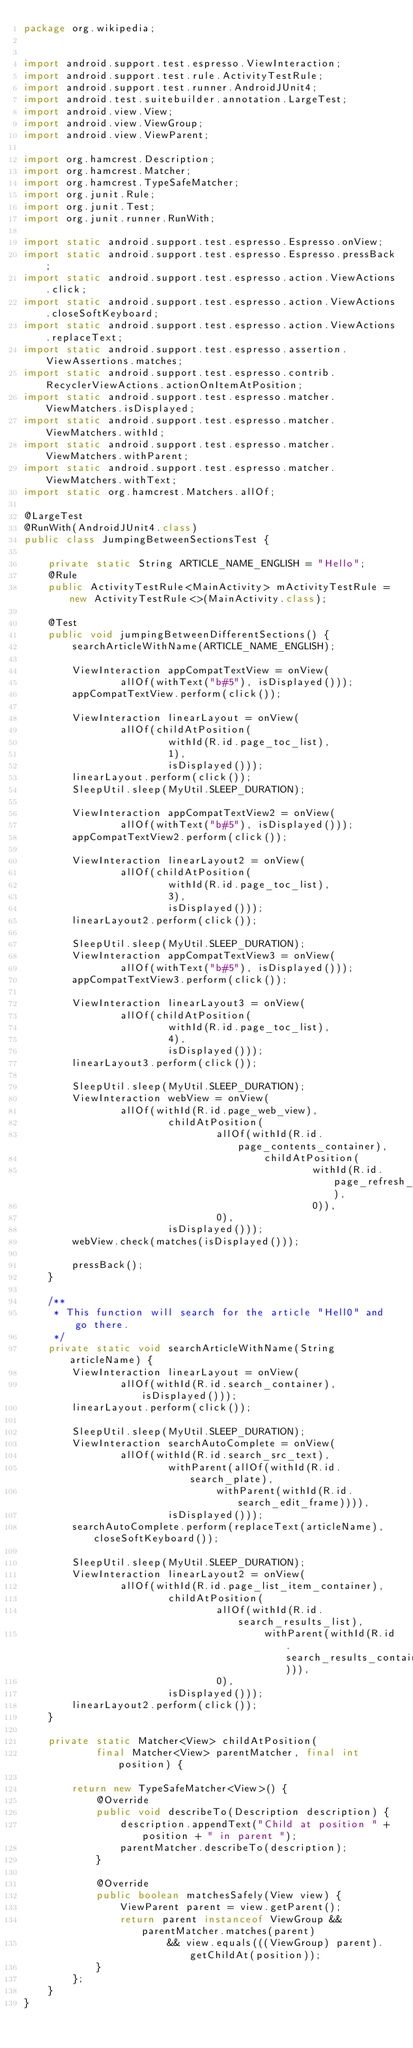<code> <loc_0><loc_0><loc_500><loc_500><_Java_>package org.wikipedia;


import android.support.test.espresso.ViewInteraction;
import android.support.test.rule.ActivityTestRule;
import android.support.test.runner.AndroidJUnit4;
import android.test.suitebuilder.annotation.LargeTest;
import android.view.View;
import android.view.ViewGroup;
import android.view.ViewParent;

import org.hamcrest.Description;
import org.hamcrest.Matcher;
import org.hamcrest.TypeSafeMatcher;
import org.junit.Rule;
import org.junit.Test;
import org.junit.runner.RunWith;

import static android.support.test.espresso.Espresso.onView;
import static android.support.test.espresso.Espresso.pressBack;
import static android.support.test.espresso.action.ViewActions.click;
import static android.support.test.espresso.action.ViewActions.closeSoftKeyboard;
import static android.support.test.espresso.action.ViewActions.replaceText;
import static android.support.test.espresso.assertion.ViewAssertions.matches;
import static android.support.test.espresso.contrib.RecyclerViewActions.actionOnItemAtPosition;
import static android.support.test.espresso.matcher.ViewMatchers.isDisplayed;
import static android.support.test.espresso.matcher.ViewMatchers.withId;
import static android.support.test.espresso.matcher.ViewMatchers.withParent;
import static android.support.test.espresso.matcher.ViewMatchers.withText;
import static org.hamcrest.Matchers.allOf;

@LargeTest
@RunWith(AndroidJUnit4.class)
public class JumpingBetweenSectionsTest {

    private static String ARTICLE_NAME_ENGLISH = "Hello";
    @Rule
    public ActivityTestRule<MainActivity> mActivityTestRule = new ActivityTestRule<>(MainActivity.class);

    @Test
    public void jumpingBetweenDifferentSections() {
        searchArticleWithName(ARTICLE_NAME_ENGLISH);

        ViewInteraction appCompatTextView = onView(
                allOf(withText("b#5"), isDisplayed()));
        appCompatTextView.perform(click());

        ViewInteraction linearLayout = onView(
                allOf(childAtPosition(
                        withId(R.id.page_toc_list),
                        1),
                        isDisplayed()));
        linearLayout.perform(click());
        SleepUtil.sleep(MyUtil.SLEEP_DURATION);

        ViewInteraction appCompatTextView2 = onView(
                allOf(withText("b#5"), isDisplayed()));
        appCompatTextView2.perform(click());

        ViewInteraction linearLayout2 = onView(
                allOf(childAtPosition(
                        withId(R.id.page_toc_list),
                        3),
                        isDisplayed()));
        linearLayout2.perform(click());

        SleepUtil.sleep(MyUtil.SLEEP_DURATION);
        ViewInteraction appCompatTextView3 = onView(
                allOf(withText("b#5"), isDisplayed()));
        appCompatTextView3.perform(click());

        ViewInteraction linearLayout3 = onView(
                allOf(childAtPosition(
                        withId(R.id.page_toc_list),
                        4),
                        isDisplayed()));
        linearLayout3.perform(click());

        SleepUtil.sleep(MyUtil.SLEEP_DURATION);
        ViewInteraction webView = onView(
                allOf(withId(R.id.page_web_view),
                        childAtPosition(
                                allOf(withId(R.id.page_contents_container),
                                        childAtPosition(
                                                withId(R.id.page_refresh_container),
                                                0)),
                                0),
                        isDisplayed()));
        webView.check(matches(isDisplayed()));

        pressBack();
    }

    /**
     * This function will search for the article "Hell0" and go there.
     */
    private static void searchArticleWithName(String articleName) {
        ViewInteraction linearLayout = onView(
                allOf(withId(R.id.search_container), isDisplayed()));
        linearLayout.perform(click());

        SleepUtil.sleep(MyUtil.SLEEP_DURATION);
        ViewInteraction searchAutoComplete = onView(
                allOf(withId(R.id.search_src_text),
                        withParent(allOf(withId(R.id.search_plate),
                                withParent(withId(R.id.search_edit_frame)))),
                        isDisplayed()));
        searchAutoComplete.perform(replaceText(articleName), closeSoftKeyboard());

        SleepUtil.sleep(MyUtil.SLEEP_DURATION);
        ViewInteraction linearLayout2 = onView(
                allOf(withId(R.id.page_list_item_container),
                        childAtPosition(
                                allOf(withId(R.id.search_results_list),
                                        withParent(withId(R.id.search_results_container))),
                                0),
                        isDisplayed()));
        linearLayout2.perform(click());
    }

    private static Matcher<View> childAtPosition(
            final Matcher<View> parentMatcher, final int position) {

        return new TypeSafeMatcher<View>() {
            @Override
            public void describeTo(Description description) {
                description.appendText("Child at position " + position + " in parent ");
                parentMatcher.describeTo(description);
            }

            @Override
            public boolean matchesSafely(View view) {
                ViewParent parent = view.getParent();
                return parent instanceof ViewGroup && parentMatcher.matches(parent)
                        && view.equals(((ViewGroup) parent).getChildAt(position));
            }
        };
    }
}
</code> 